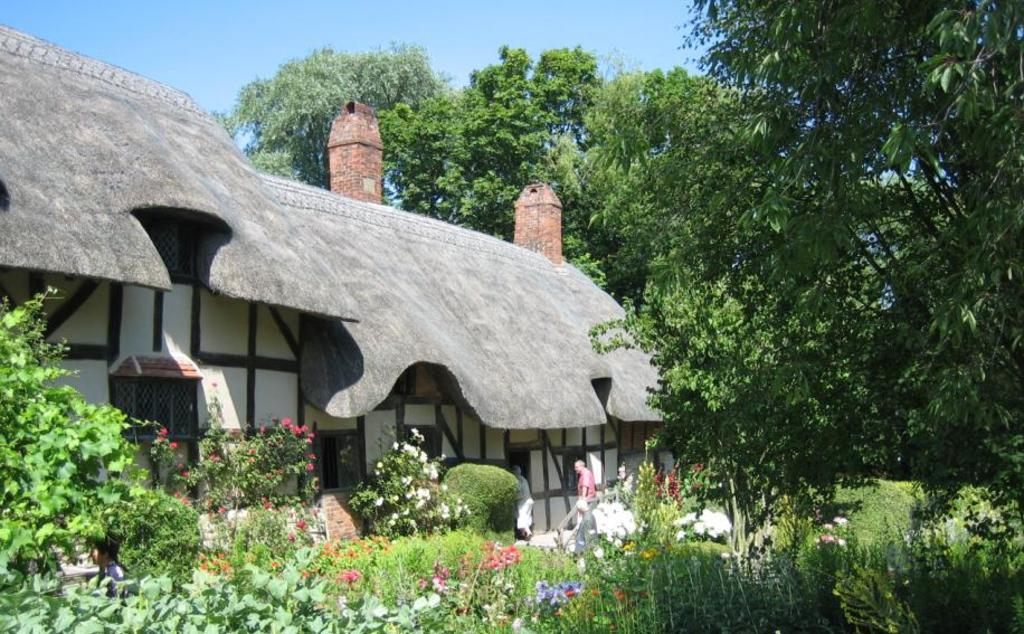What type of vegetation can be seen in the image? There are flowers on the plants and plant bushes in the image. Are there any people present in the image? Yes, there are people standing in the image. What can be seen in the background of the image? There are many trees in the background of the image. How is the sky depicted in the image? The sky is clear in the image. What type of knot is being tied by the people in the image? There is no knot-tying activity depicted in the image; the people are simply standing. What room is the image taken in? The image does not show a room; it appears to be an outdoor scene with trees and plants. 